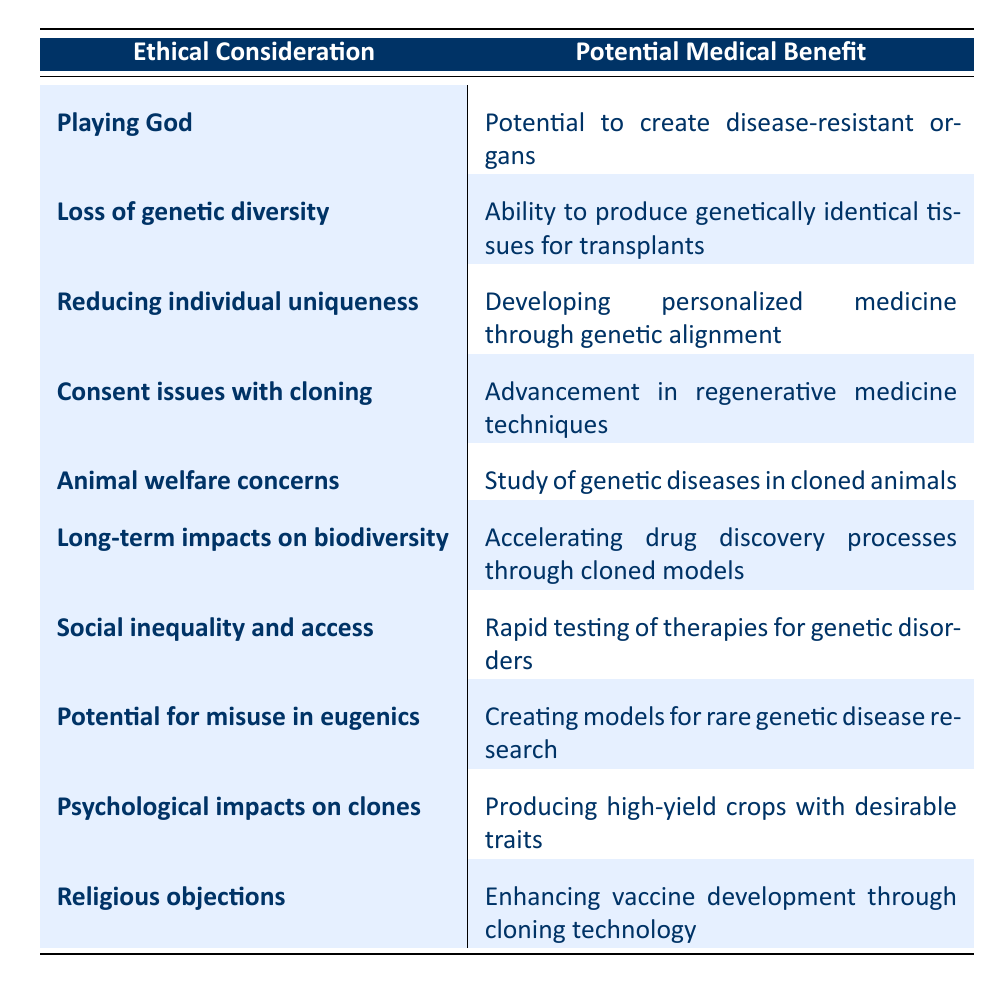What ethical consideration is associated with the potential to create disease-resistant organs? The table shows that the ethical consideration "Playing God" is directly linked to the medical benefit "Potential to create disease-resistant organs."
Answer: Playing God What medical benefit is linked to the ethical concern of loss of genetic diversity? The ethical consideration "Loss of genetic diversity" is matched with the medical benefit "Ability to produce genetically identical tissues for transplants" in the table.
Answer: Ability to produce genetically identical tissues for transplants How many ethical considerations are listed in the table? The table presents 10 rows, each representing a distinct ethical consideration paired with a medical benefit. Therefore, there are 10 ethical considerations listed.
Answer: 10 Is there an ethical consideration addressing social inequality? There is indeed an ethical consideration labeled "Social inequality and access" in the table, signifying a valid concern associated with genetic cloning.
Answer: Yes What is the relationship between the potential for misuse in eugenics and medical research? The table indicates that the ethical consideration of "Potential for misuse in eugenics" is coupled with the medical benefit "Creating models for rare genetic disease research." This illustrates that while eugenics raises ethical questions, it can also lead to valuable research advancements.
Answer: Creating models for rare genetic disease research What is the average number of medical benefits listed for the given ethical considerations? There are 10 ethical considerations, each paired with one medical benefit, making the total number of medical benefits also 10. Thus, the average number of medical benefits per ethical consideration is 1 (10/10 = 1).
Answer: 1 Which ethical consideration relates to advancing vaccine development? The ethical consideration that corresponds to enhancing vaccine development is "Religious objections," as indicated in the table alongside its medical benefit.
Answer: Religious objections Is the psychological impact on clones considered an ethical concern in this table? Yes, the ethical consideration "Psychological impacts on clones" is present in the table, which confirms that this is indeed a concern addressed.
Answer: Yes What medical benefit is associated with consent issues in cloning? According to the table, the ethical consideration "Consent issues with cloning" is tied to the medical benefit "Advancement in regenerative medicine techniques."
Answer: Advancement in regenerative medicine techniques 